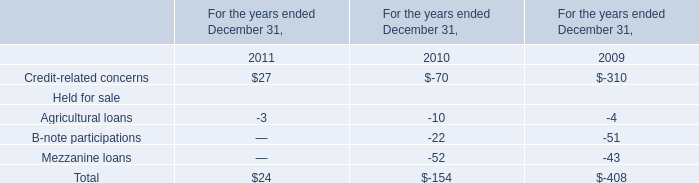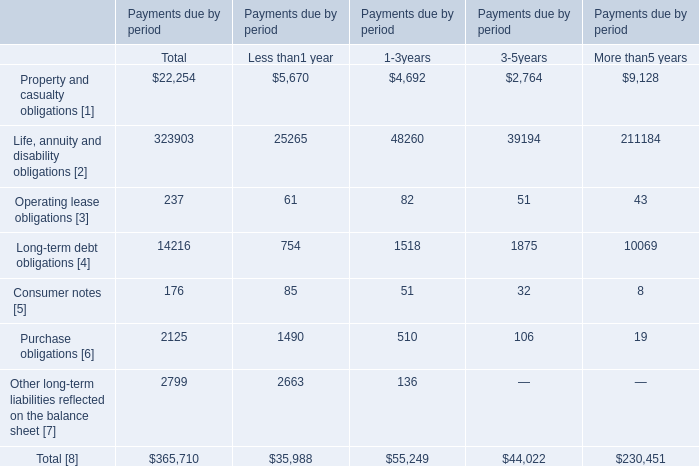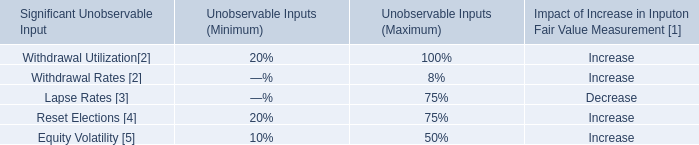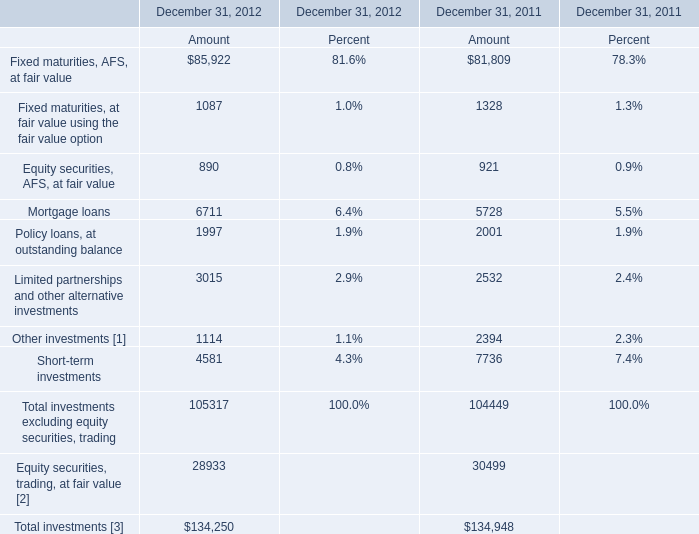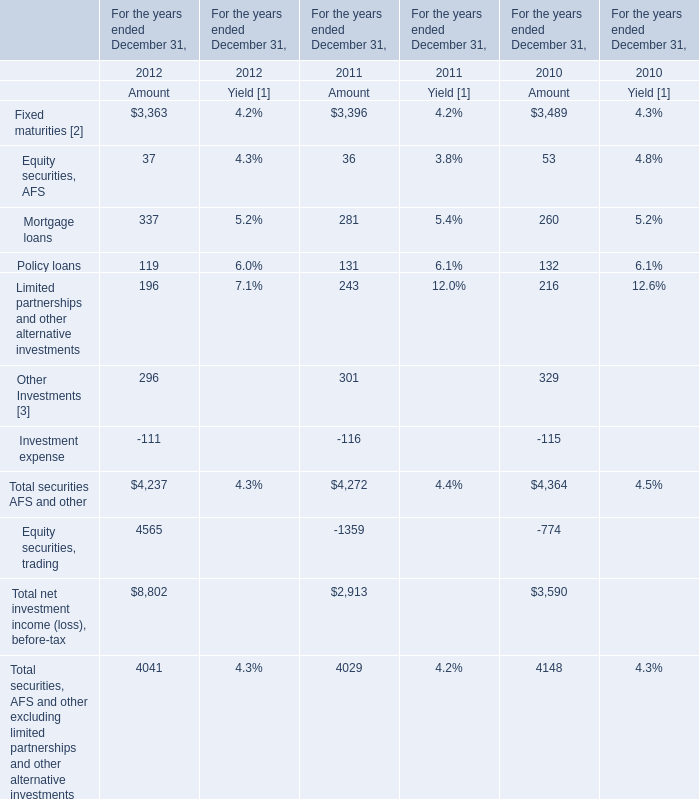In the year with larger Amount of Total investments excluding equity securities, trading, what's the increasing rate of Amount of Limited partnerships and other alternative investments? 
Computations: ((3015 - 2532) / 2532)
Answer: 0.19076. 